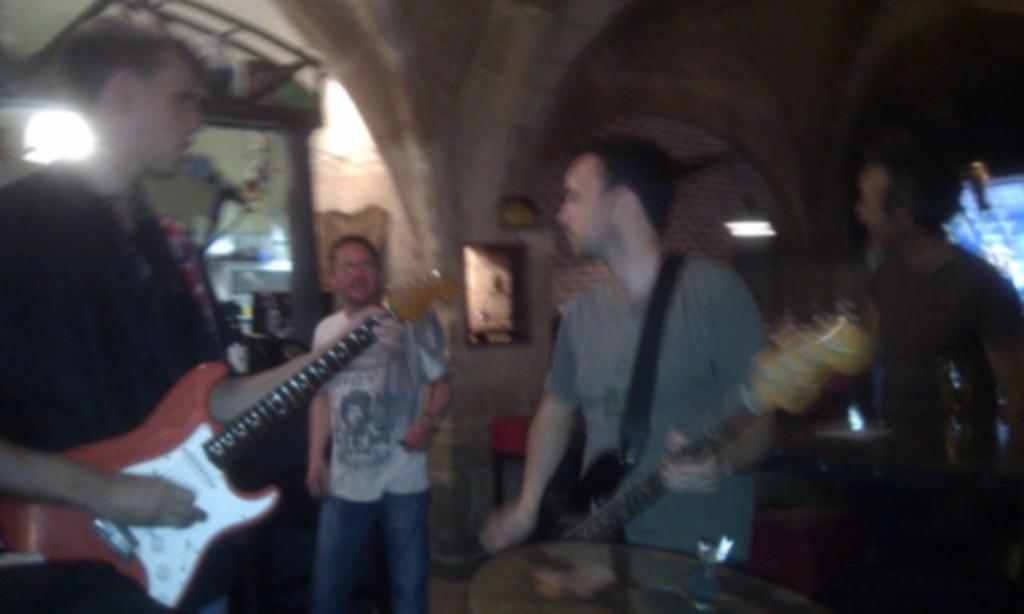Can you describe this image briefly? Here we can see a man standing on the floor and holding a guitar in his hands, and in front there is the table, and and here a person is standing and here a man is standing and holding a guitar in his hands, and here is the light, and here is the wall. 